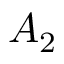<formula> <loc_0><loc_0><loc_500><loc_500>A _ { 2 }</formula> 